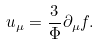Convert formula to latex. <formula><loc_0><loc_0><loc_500><loc_500>u _ { \mu } = \frac { 3 } { \Phi } \partial _ { \mu } f .</formula> 